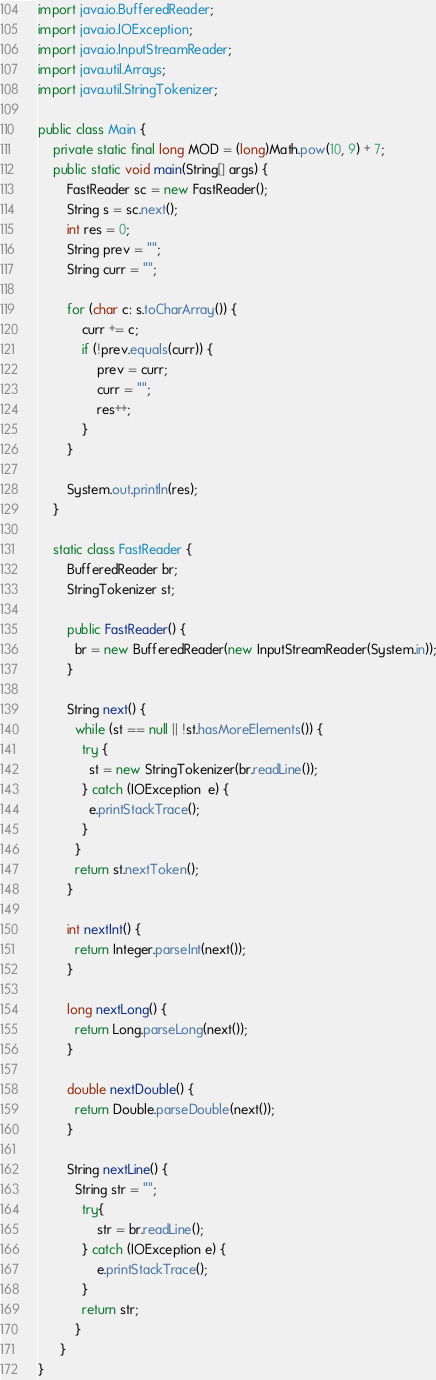<code> <loc_0><loc_0><loc_500><loc_500><_Java_>
import java.io.BufferedReader;
import java.io.IOException;
import java.io.InputStreamReader;
import java.util.Arrays;
import java.util.StringTokenizer;

public class Main {
	private static final long MOD = (long)Math.pow(10, 9) + 7;
	public static void main(String[] args) {
		FastReader sc = new FastReader();
		String s = sc.next();
		int res = 0;
		String prev = "";
		String curr = "";
		
		for (char c: s.toCharArray()) {
			curr += c;
			if (!prev.equals(curr)) {
				prev = curr;
				curr = "";
				res++;
			}
		}
		
		System.out.println(res);
	}
	
	static class FastReader {
	    BufferedReader br;
	    StringTokenizer st;
	
	    public FastReader() {
	      br = new BufferedReader(new InputStreamReader(System.in));
	    }
	  
	    String next() { 
	      while (st == null || !st.hasMoreElements()) {
	        try {
	          st = new StringTokenizer(br.readLine());
	        } catch (IOException  e) {
	          e.printStackTrace();
	        }
	      }
	      return st.nextToken();
	    }
	
	    int nextInt() {
	      return Integer.parseInt(next());
	    }
	
	    long nextLong() {
	      return Long.parseLong(next());
	    }
	
	    double nextDouble() { 
	      return Double.parseDouble(next());
	    }
	
	    String nextLine() {
	      String str = "";
	        try{
	            str = br.readLine();
	        } catch (IOException e) {
	            e.printStackTrace();
	        }
	        return str;
	      }
	  }
}
</code> 